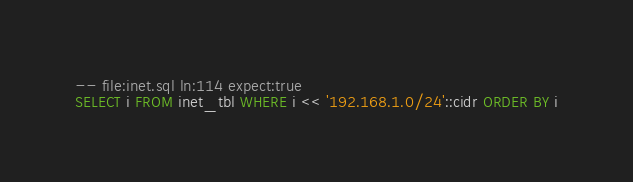<code> <loc_0><loc_0><loc_500><loc_500><_SQL_>-- file:inet.sql ln:114 expect:true
SELECT i FROM inet_tbl WHERE i << '192.168.1.0/24'::cidr ORDER BY i
</code> 